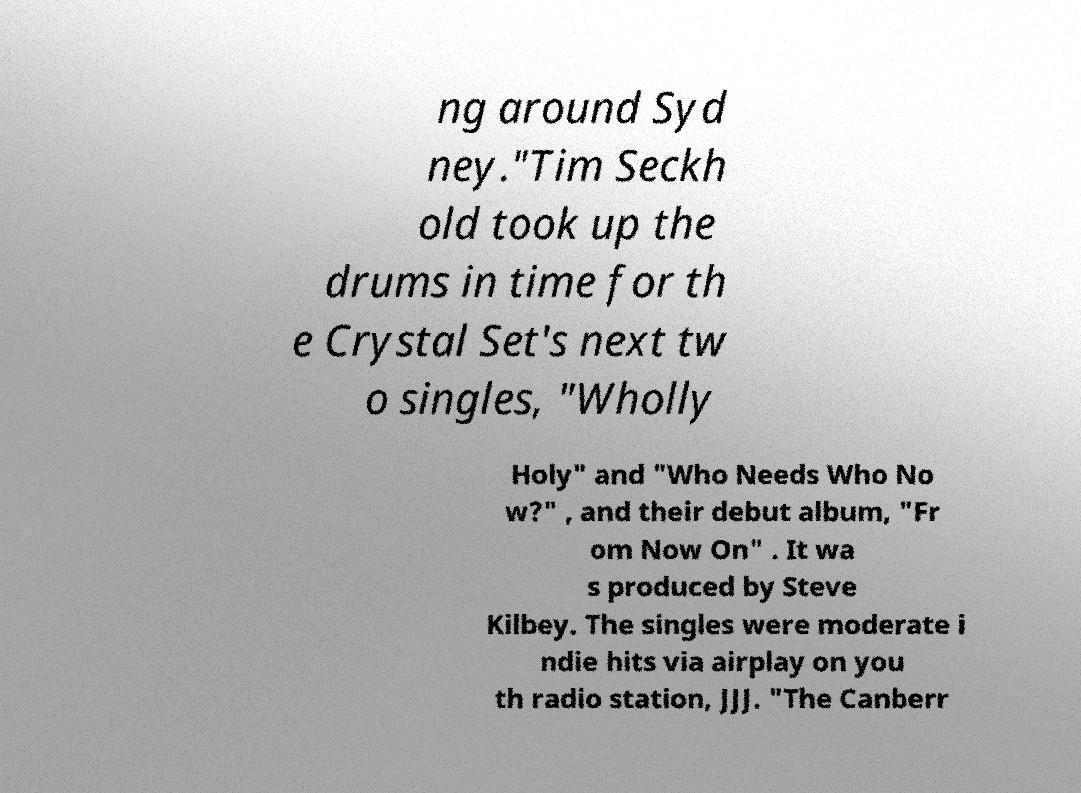I need the written content from this picture converted into text. Can you do that? ng around Syd ney."Tim Seckh old took up the drums in time for th e Crystal Set's next tw o singles, "Wholly Holy" and "Who Needs Who No w?" , and their debut album, "Fr om Now On" . It wa s produced by Steve Kilbey. The singles were moderate i ndie hits via airplay on you th radio station, JJJ. "The Canberr 